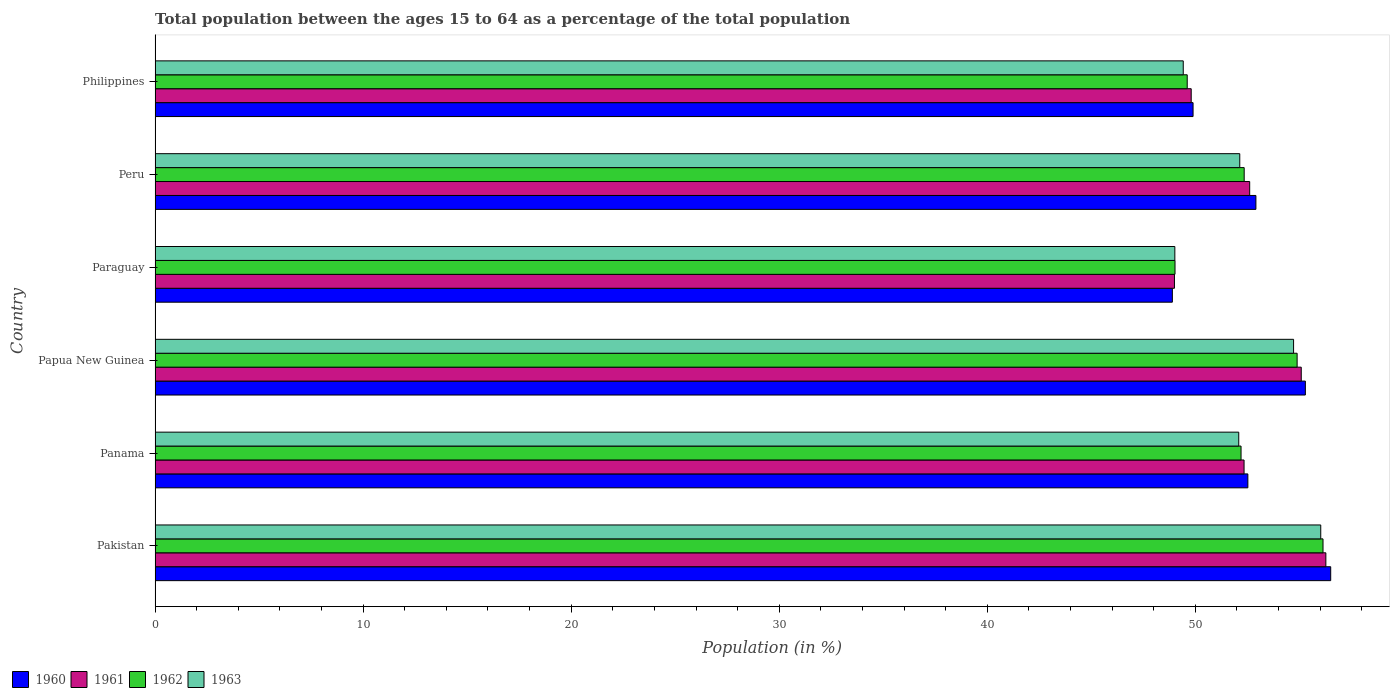How many different coloured bars are there?
Keep it short and to the point. 4. How many groups of bars are there?
Provide a short and direct response. 6. How many bars are there on the 5th tick from the bottom?
Your response must be concise. 4. What is the label of the 4th group of bars from the top?
Give a very brief answer. Papua New Guinea. What is the percentage of the population ages 15 to 64 in 1963 in Paraguay?
Your answer should be very brief. 49.01. Across all countries, what is the maximum percentage of the population ages 15 to 64 in 1961?
Your answer should be compact. 56.27. Across all countries, what is the minimum percentage of the population ages 15 to 64 in 1960?
Provide a short and direct response. 48.9. In which country was the percentage of the population ages 15 to 64 in 1961 maximum?
Offer a terse response. Pakistan. In which country was the percentage of the population ages 15 to 64 in 1961 minimum?
Offer a terse response. Paraguay. What is the total percentage of the population ages 15 to 64 in 1961 in the graph?
Provide a short and direct response. 315.11. What is the difference between the percentage of the population ages 15 to 64 in 1960 in Paraguay and that in Philippines?
Your answer should be compact. -0.99. What is the difference between the percentage of the population ages 15 to 64 in 1960 in Peru and the percentage of the population ages 15 to 64 in 1962 in Pakistan?
Offer a very short reply. -3.23. What is the average percentage of the population ages 15 to 64 in 1962 per country?
Keep it short and to the point. 52.37. What is the difference between the percentage of the population ages 15 to 64 in 1960 and percentage of the population ages 15 to 64 in 1963 in Paraguay?
Keep it short and to the point. -0.12. In how many countries, is the percentage of the population ages 15 to 64 in 1963 greater than 16 ?
Provide a short and direct response. 6. What is the ratio of the percentage of the population ages 15 to 64 in 1960 in Paraguay to that in Philippines?
Provide a succinct answer. 0.98. Is the percentage of the population ages 15 to 64 in 1961 in Pakistan less than that in Paraguay?
Make the answer very short. No. Is the difference between the percentage of the population ages 15 to 64 in 1960 in Panama and Philippines greater than the difference between the percentage of the population ages 15 to 64 in 1963 in Panama and Philippines?
Give a very brief answer. No. What is the difference between the highest and the second highest percentage of the population ages 15 to 64 in 1963?
Provide a short and direct response. 1.31. What is the difference between the highest and the lowest percentage of the population ages 15 to 64 in 1962?
Your answer should be very brief. 7.11. What does the 3rd bar from the top in Papua New Guinea represents?
Offer a terse response. 1961. Is it the case that in every country, the sum of the percentage of the population ages 15 to 64 in 1963 and percentage of the population ages 15 to 64 in 1960 is greater than the percentage of the population ages 15 to 64 in 1962?
Your response must be concise. Yes. Are all the bars in the graph horizontal?
Your response must be concise. Yes. How many countries are there in the graph?
Your answer should be compact. 6. Does the graph contain grids?
Your answer should be compact. No. What is the title of the graph?
Keep it short and to the point. Total population between the ages 15 to 64 as a percentage of the total population. Does "1976" appear as one of the legend labels in the graph?
Provide a succinct answer. No. What is the label or title of the X-axis?
Offer a very short reply. Population (in %). What is the Population (in %) of 1960 in Pakistan?
Give a very brief answer. 56.51. What is the Population (in %) of 1961 in Pakistan?
Make the answer very short. 56.27. What is the Population (in %) in 1962 in Pakistan?
Make the answer very short. 56.14. What is the Population (in %) of 1963 in Pakistan?
Provide a short and direct response. 56.03. What is the Population (in %) of 1960 in Panama?
Offer a terse response. 52.52. What is the Population (in %) in 1961 in Panama?
Your answer should be very brief. 52.34. What is the Population (in %) in 1962 in Panama?
Provide a succinct answer. 52.2. What is the Population (in %) of 1963 in Panama?
Give a very brief answer. 52.09. What is the Population (in %) in 1960 in Papua New Guinea?
Your answer should be very brief. 55.29. What is the Population (in %) of 1961 in Papua New Guinea?
Give a very brief answer. 55.09. What is the Population (in %) in 1962 in Papua New Guinea?
Keep it short and to the point. 54.89. What is the Population (in %) of 1963 in Papua New Guinea?
Keep it short and to the point. 54.72. What is the Population (in %) of 1960 in Paraguay?
Your answer should be very brief. 48.9. What is the Population (in %) of 1961 in Paraguay?
Give a very brief answer. 49. What is the Population (in %) of 1962 in Paraguay?
Provide a succinct answer. 49.02. What is the Population (in %) in 1963 in Paraguay?
Give a very brief answer. 49.01. What is the Population (in %) in 1960 in Peru?
Offer a terse response. 52.91. What is the Population (in %) of 1961 in Peru?
Your answer should be compact. 52.61. What is the Population (in %) of 1962 in Peru?
Ensure brevity in your answer.  52.35. What is the Population (in %) of 1963 in Peru?
Your answer should be very brief. 52.13. What is the Population (in %) in 1960 in Philippines?
Keep it short and to the point. 49.89. What is the Population (in %) of 1961 in Philippines?
Your answer should be very brief. 49.8. What is the Population (in %) in 1962 in Philippines?
Give a very brief answer. 49.61. What is the Population (in %) of 1963 in Philippines?
Make the answer very short. 49.42. Across all countries, what is the maximum Population (in %) in 1960?
Ensure brevity in your answer.  56.51. Across all countries, what is the maximum Population (in %) in 1961?
Provide a short and direct response. 56.27. Across all countries, what is the maximum Population (in %) in 1962?
Offer a terse response. 56.14. Across all countries, what is the maximum Population (in %) of 1963?
Give a very brief answer. 56.03. Across all countries, what is the minimum Population (in %) of 1960?
Your answer should be very brief. 48.9. Across all countries, what is the minimum Population (in %) of 1961?
Your response must be concise. 49. Across all countries, what is the minimum Population (in %) of 1962?
Offer a very short reply. 49.02. Across all countries, what is the minimum Population (in %) of 1963?
Give a very brief answer. 49.01. What is the total Population (in %) of 1960 in the graph?
Give a very brief answer. 316.01. What is the total Population (in %) of 1961 in the graph?
Keep it short and to the point. 315.11. What is the total Population (in %) of 1962 in the graph?
Offer a terse response. 314.2. What is the total Population (in %) of 1963 in the graph?
Your response must be concise. 313.4. What is the difference between the Population (in %) in 1960 in Pakistan and that in Panama?
Your answer should be compact. 3.98. What is the difference between the Population (in %) in 1961 in Pakistan and that in Panama?
Give a very brief answer. 3.93. What is the difference between the Population (in %) of 1962 in Pakistan and that in Panama?
Make the answer very short. 3.94. What is the difference between the Population (in %) of 1963 in Pakistan and that in Panama?
Offer a terse response. 3.94. What is the difference between the Population (in %) of 1960 in Pakistan and that in Papua New Guinea?
Make the answer very short. 1.22. What is the difference between the Population (in %) of 1961 in Pakistan and that in Papua New Guinea?
Your response must be concise. 1.18. What is the difference between the Population (in %) in 1962 in Pakistan and that in Papua New Guinea?
Provide a short and direct response. 1.24. What is the difference between the Population (in %) of 1963 in Pakistan and that in Papua New Guinea?
Offer a very short reply. 1.31. What is the difference between the Population (in %) in 1960 in Pakistan and that in Paraguay?
Your response must be concise. 7.61. What is the difference between the Population (in %) in 1961 in Pakistan and that in Paraguay?
Give a very brief answer. 7.28. What is the difference between the Population (in %) of 1962 in Pakistan and that in Paraguay?
Your answer should be compact. 7.11. What is the difference between the Population (in %) in 1963 in Pakistan and that in Paraguay?
Your answer should be compact. 7.01. What is the difference between the Population (in %) of 1960 in Pakistan and that in Peru?
Your response must be concise. 3.6. What is the difference between the Population (in %) in 1961 in Pakistan and that in Peru?
Your answer should be compact. 3.66. What is the difference between the Population (in %) of 1962 in Pakistan and that in Peru?
Your answer should be compact. 3.79. What is the difference between the Population (in %) of 1963 in Pakistan and that in Peru?
Ensure brevity in your answer.  3.89. What is the difference between the Population (in %) of 1960 in Pakistan and that in Philippines?
Your answer should be compact. 6.62. What is the difference between the Population (in %) of 1961 in Pakistan and that in Philippines?
Offer a very short reply. 6.47. What is the difference between the Population (in %) of 1962 in Pakistan and that in Philippines?
Your answer should be compact. 6.53. What is the difference between the Population (in %) of 1963 in Pakistan and that in Philippines?
Ensure brevity in your answer.  6.61. What is the difference between the Population (in %) of 1960 in Panama and that in Papua New Guinea?
Make the answer very short. -2.76. What is the difference between the Population (in %) of 1961 in Panama and that in Papua New Guinea?
Give a very brief answer. -2.75. What is the difference between the Population (in %) of 1962 in Panama and that in Papua New Guinea?
Your answer should be very brief. -2.7. What is the difference between the Population (in %) in 1963 in Panama and that in Papua New Guinea?
Your response must be concise. -2.64. What is the difference between the Population (in %) in 1960 in Panama and that in Paraguay?
Your answer should be very brief. 3.63. What is the difference between the Population (in %) in 1961 in Panama and that in Paraguay?
Provide a succinct answer. 3.35. What is the difference between the Population (in %) of 1962 in Panama and that in Paraguay?
Your answer should be compact. 3.17. What is the difference between the Population (in %) in 1963 in Panama and that in Paraguay?
Keep it short and to the point. 3.07. What is the difference between the Population (in %) in 1960 in Panama and that in Peru?
Give a very brief answer. -0.39. What is the difference between the Population (in %) in 1961 in Panama and that in Peru?
Your answer should be compact. -0.27. What is the difference between the Population (in %) in 1962 in Panama and that in Peru?
Give a very brief answer. -0.15. What is the difference between the Population (in %) of 1963 in Panama and that in Peru?
Ensure brevity in your answer.  -0.05. What is the difference between the Population (in %) of 1960 in Panama and that in Philippines?
Offer a very short reply. 2.63. What is the difference between the Population (in %) of 1961 in Panama and that in Philippines?
Offer a terse response. 2.54. What is the difference between the Population (in %) of 1962 in Panama and that in Philippines?
Your answer should be compact. 2.59. What is the difference between the Population (in %) of 1963 in Panama and that in Philippines?
Provide a succinct answer. 2.67. What is the difference between the Population (in %) of 1960 in Papua New Guinea and that in Paraguay?
Provide a short and direct response. 6.39. What is the difference between the Population (in %) of 1961 in Papua New Guinea and that in Paraguay?
Give a very brief answer. 6.09. What is the difference between the Population (in %) in 1962 in Papua New Guinea and that in Paraguay?
Keep it short and to the point. 5.87. What is the difference between the Population (in %) of 1963 in Papua New Guinea and that in Paraguay?
Offer a terse response. 5.71. What is the difference between the Population (in %) of 1960 in Papua New Guinea and that in Peru?
Give a very brief answer. 2.38. What is the difference between the Population (in %) in 1961 in Papua New Guinea and that in Peru?
Your response must be concise. 2.48. What is the difference between the Population (in %) of 1962 in Papua New Guinea and that in Peru?
Ensure brevity in your answer.  2.55. What is the difference between the Population (in %) in 1963 in Papua New Guinea and that in Peru?
Offer a terse response. 2.59. What is the difference between the Population (in %) in 1960 in Papua New Guinea and that in Philippines?
Ensure brevity in your answer.  5.4. What is the difference between the Population (in %) of 1961 in Papua New Guinea and that in Philippines?
Keep it short and to the point. 5.29. What is the difference between the Population (in %) in 1962 in Papua New Guinea and that in Philippines?
Your response must be concise. 5.28. What is the difference between the Population (in %) in 1963 in Papua New Guinea and that in Philippines?
Your response must be concise. 5.3. What is the difference between the Population (in %) of 1960 in Paraguay and that in Peru?
Provide a short and direct response. -4.02. What is the difference between the Population (in %) in 1961 in Paraguay and that in Peru?
Provide a succinct answer. -3.62. What is the difference between the Population (in %) in 1962 in Paraguay and that in Peru?
Ensure brevity in your answer.  -3.32. What is the difference between the Population (in %) of 1963 in Paraguay and that in Peru?
Provide a short and direct response. -3.12. What is the difference between the Population (in %) in 1960 in Paraguay and that in Philippines?
Offer a terse response. -0.99. What is the difference between the Population (in %) of 1961 in Paraguay and that in Philippines?
Ensure brevity in your answer.  -0.81. What is the difference between the Population (in %) in 1962 in Paraguay and that in Philippines?
Your response must be concise. -0.59. What is the difference between the Population (in %) of 1963 in Paraguay and that in Philippines?
Your answer should be compact. -0.4. What is the difference between the Population (in %) in 1960 in Peru and that in Philippines?
Give a very brief answer. 3.02. What is the difference between the Population (in %) of 1961 in Peru and that in Philippines?
Give a very brief answer. 2.81. What is the difference between the Population (in %) in 1962 in Peru and that in Philippines?
Keep it short and to the point. 2.74. What is the difference between the Population (in %) in 1963 in Peru and that in Philippines?
Offer a terse response. 2.72. What is the difference between the Population (in %) of 1960 in Pakistan and the Population (in %) of 1961 in Panama?
Make the answer very short. 4.16. What is the difference between the Population (in %) in 1960 in Pakistan and the Population (in %) in 1962 in Panama?
Ensure brevity in your answer.  4.31. What is the difference between the Population (in %) in 1960 in Pakistan and the Population (in %) in 1963 in Panama?
Your response must be concise. 4.42. What is the difference between the Population (in %) of 1961 in Pakistan and the Population (in %) of 1962 in Panama?
Provide a succinct answer. 4.08. What is the difference between the Population (in %) of 1961 in Pakistan and the Population (in %) of 1963 in Panama?
Provide a succinct answer. 4.19. What is the difference between the Population (in %) in 1962 in Pakistan and the Population (in %) in 1963 in Panama?
Keep it short and to the point. 4.05. What is the difference between the Population (in %) in 1960 in Pakistan and the Population (in %) in 1961 in Papua New Guinea?
Provide a succinct answer. 1.42. What is the difference between the Population (in %) of 1960 in Pakistan and the Population (in %) of 1962 in Papua New Guinea?
Offer a terse response. 1.61. What is the difference between the Population (in %) of 1960 in Pakistan and the Population (in %) of 1963 in Papua New Guinea?
Keep it short and to the point. 1.78. What is the difference between the Population (in %) of 1961 in Pakistan and the Population (in %) of 1962 in Papua New Guinea?
Ensure brevity in your answer.  1.38. What is the difference between the Population (in %) in 1961 in Pakistan and the Population (in %) in 1963 in Papua New Guinea?
Your response must be concise. 1.55. What is the difference between the Population (in %) of 1962 in Pakistan and the Population (in %) of 1963 in Papua New Guinea?
Your response must be concise. 1.41. What is the difference between the Population (in %) of 1960 in Pakistan and the Population (in %) of 1961 in Paraguay?
Provide a short and direct response. 7.51. What is the difference between the Population (in %) of 1960 in Pakistan and the Population (in %) of 1962 in Paraguay?
Your response must be concise. 7.48. What is the difference between the Population (in %) of 1960 in Pakistan and the Population (in %) of 1963 in Paraguay?
Make the answer very short. 7.49. What is the difference between the Population (in %) of 1961 in Pakistan and the Population (in %) of 1962 in Paraguay?
Your response must be concise. 7.25. What is the difference between the Population (in %) in 1961 in Pakistan and the Population (in %) in 1963 in Paraguay?
Your answer should be very brief. 7.26. What is the difference between the Population (in %) in 1962 in Pakistan and the Population (in %) in 1963 in Paraguay?
Your answer should be compact. 7.12. What is the difference between the Population (in %) in 1960 in Pakistan and the Population (in %) in 1961 in Peru?
Provide a short and direct response. 3.89. What is the difference between the Population (in %) of 1960 in Pakistan and the Population (in %) of 1962 in Peru?
Give a very brief answer. 4.16. What is the difference between the Population (in %) of 1960 in Pakistan and the Population (in %) of 1963 in Peru?
Your answer should be very brief. 4.37. What is the difference between the Population (in %) of 1961 in Pakistan and the Population (in %) of 1962 in Peru?
Your answer should be compact. 3.93. What is the difference between the Population (in %) in 1961 in Pakistan and the Population (in %) in 1963 in Peru?
Provide a succinct answer. 4.14. What is the difference between the Population (in %) in 1962 in Pakistan and the Population (in %) in 1963 in Peru?
Your response must be concise. 4. What is the difference between the Population (in %) in 1960 in Pakistan and the Population (in %) in 1961 in Philippines?
Keep it short and to the point. 6.71. What is the difference between the Population (in %) of 1960 in Pakistan and the Population (in %) of 1962 in Philippines?
Keep it short and to the point. 6.9. What is the difference between the Population (in %) of 1960 in Pakistan and the Population (in %) of 1963 in Philippines?
Make the answer very short. 7.09. What is the difference between the Population (in %) in 1961 in Pakistan and the Population (in %) in 1962 in Philippines?
Make the answer very short. 6.66. What is the difference between the Population (in %) in 1961 in Pakistan and the Population (in %) in 1963 in Philippines?
Provide a succinct answer. 6.85. What is the difference between the Population (in %) of 1962 in Pakistan and the Population (in %) of 1963 in Philippines?
Provide a short and direct response. 6.72. What is the difference between the Population (in %) in 1960 in Panama and the Population (in %) in 1961 in Papua New Guinea?
Provide a short and direct response. -2.57. What is the difference between the Population (in %) in 1960 in Panama and the Population (in %) in 1962 in Papua New Guinea?
Your response must be concise. -2.37. What is the difference between the Population (in %) in 1960 in Panama and the Population (in %) in 1963 in Papua New Guinea?
Make the answer very short. -2.2. What is the difference between the Population (in %) of 1961 in Panama and the Population (in %) of 1962 in Papua New Guinea?
Your answer should be compact. -2.55. What is the difference between the Population (in %) in 1961 in Panama and the Population (in %) in 1963 in Papua New Guinea?
Offer a terse response. -2.38. What is the difference between the Population (in %) in 1962 in Panama and the Population (in %) in 1963 in Papua New Guinea?
Your answer should be very brief. -2.52. What is the difference between the Population (in %) of 1960 in Panama and the Population (in %) of 1961 in Paraguay?
Provide a succinct answer. 3.53. What is the difference between the Population (in %) in 1960 in Panama and the Population (in %) in 1962 in Paraguay?
Make the answer very short. 3.5. What is the difference between the Population (in %) of 1960 in Panama and the Population (in %) of 1963 in Paraguay?
Keep it short and to the point. 3.51. What is the difference between the Population (in %) in 1961 in Panama and the Population (in %) in 1962 in Paraguay?
Your answer should be very brief. 3.32. What is the difference between the Population (in %) of 1961 in Panama and the Population (in %) of 1963 in Paraguay?
Provide a succinct answer. 3.33. What is the difference between the Population (in %) of 1962 in Panama and the Population (in %) of 1963 in Paraguay?
Offer a very short reply. 3.18. What is the difference between the Population (in %) in 1960 in Panama and the Population (in %) in 1961 in Peru?
Offer a terse response. -0.09. What is the difference between the Population (in %) of 1960 in Panama and the Population (in %) of 1962 in Peru?
Provide a short and direct response. 0.18. What is the difference between the Population (in %) of 1960 in Panama and the Population (in %) of 1963 in Peru?
Ensure brevity in your answer.  0.39. What is the difference between the Population (in %) in 1961 in Panama and the Population (in %) in 1962 in Peru?
Your answer should be compact. -0.01. What is the difference between the Population (in %) in 1961 in Panama and the Population (in %) in 1963 in Peru?
Provide a short and direct response. 0.21. What is the difference between the Population (in %) in 1962 in Panama and the Population (in %) in 1963 in Peru?
Offer a very short reply. 0.06. What is the difference between the Population (in %) in 1960 in Panama and the Population (in %) in 1961 in Philippines?
Offer a terse response. 2.72. What is the difference between the Population (in %) of 1960 in Panama and the Population (in %) of 1962 in Philippines?
Ensure brevity in your answer.  2.91. What is the difference between the Population (in %) of 1960 in Panama and the Population (in %) of 1963 in Philippines?
Provide a short and direct response. 3.11. What is the difference between the Population (in %) of 1961 in Panama and the Population (in %) of 1962 in Philippines?
Provide a short and direct response. 2.73. What is the difference between the Population (in %) of 1961 in Panama and the Population (in %) of 1963 in Philippines?
Ensure brevity in your answer.  2.92. What is the difference between the Population (in %) of 1962 in Panama and the Population (in %) of 1963 in Philippines?
Give a very brief answer. 2.78. What is the difference between the Population (in %) of 1960 in Papua New Guinea and the Population (in %) of 1961 in Paraguay?
Give a very brief answer. 6.29. What is the difference between the Population (in %) of 1960 in Papua New Guinea and the Population (in %) of 1962 in Paraguay?
Your response must be concise. 6.27. What is the difference between the Population (in %) in 1960 in Papua New Guinea and the Population (in %) in 1963 in Paraguay?
Offer a terse response. 6.27. What is the difference between the Population (in %) of 1961 in Papua New Guinea and the Population (in %) of 1962 in Paraguay?
Your answer should be very brief. 6.07. What is the difference between the Population (in %) in 1961 in Papua New Guinea and the Population (in %) in 1963 in Paraguay?
Your response must be concise. 6.08. What is the difference between the Population (in %) of 1962 in Papua New Guinea and the Population (in %) of 1963 in Paraguay?
Your answer should be compact. 5.88. What is the difference between the Population (in %) in 1960 in Papua New Guinea and the Population (in %) in 1961 in Peru?
Provide a short and direct response. 2.68. What is the difference between the Population (in %) in 1960 in Papua New Guinea and the Population (in %) in 1962 in Peru?
Your answer should be compact. 2.94. What is the difference between the Population (in %) of 1960 in Papua New Guinea and the Population (in %) of 1963 in Peru?
Your answer should be very brief. 3.15. What is the difference between the Population (in %) in 1961 in Papua New Guinea and the Population (in %) in 1962 in Peru?
Provide a succinct answer. 2.74. What is the difference between the Population (in %) of 1961 in Papua New Guinea and the Population (in %) of 1963 in Peru?
Your answer should be compact. 2.96. What is the difference between the Population (in %) of 1962 in Papua New Guinea and the Population (in %) of 1963 in Peru?
Your answer should be very brief. 2.76. What is the difference between the Population (in %) in 1960 in Papua New Guinea and the Population (in %) in 1961 in Philippines?
Your answer should be very brief. 5.49. What is the difference between the Population (in %) of 1960 in Papua New Guinea and the Population (in %) of 1962 in Philippines?
Provide a short and direct response. 5.68. What is the difference between the Population (in %) in 1960 in Papua New Guinea and the Population (in %) in 1963 in Philippines?
Offer a terse response. 5.87. What is the difference between the Population (in %) in 1961 in Papua New Guinea and the Population (in %) in 1962 in Philippines?
Give a very brief answer. 5.48. What is the difference between the Population (in %) in 1961 in Papua New Guinea and the Population (in %) in 1963 in Philippines?
Offer a terse response. 5.67. What is the difference between the Population (in %) of 1962 in Papua New Guinea and the Population (in %) of 1963 in Philippines?
Your response must be concise. 5.47. What is the difference between the Population (in %) of 1960 in Paraguay and the Population (in %) of 1961 in Peru?
Offer a very short reply. -3.72. What is the difference between the Population (in %) in 1960 in Paraguay and the Population (in %) in 1962 in Peru?
Provide a succinct answer. -3.45. What is the difference between the Population (in %) in 1960 in Paraguay and the Population (in %) in 1963 in Peru?
Offer a terse response. -3.24. What is the difference between the Population (in %) of 1961 in Paraguay and the Population (in %) of 1962 in Peru?
Offer a very short reply. -3.35. What is the difference between the Population (in %) of 1961 in Paraguay and the Population (in %) of 1963 in Peru?
Offer a terse response. -3.14. What is the difference between the Population (in %) in 1962 in Paraguay and the Population (in %) in 1963 in Peru?
Offer a very short reply. -3.11. What is the difference between the Population (in %) of 1960 in Paraguay and the Population (in %) of 1961 in Philippines?
Offer a terse response. -0.91. What is the difference between the Population (in %) of 1960 in Paraguay and the Population (in %) of 1962 in Philippines?
Your response must be concise. -0.71. What is the difference between the Population (in %) of 1960 in Paraguay and the Population (in %) of 1963 in Philippines?
Provide a short and direct response. -0.52. What is the difference between the Population (in %) in 1961 in Paraguay and the Population (in %) in 1962 in Philippines?
Your answer should be very brief. -0.61. What is the difference between the Population (in %) in 1961 in Paraguay and the Population (in %) in 1963 in Philippines?
Your answer should be compact. -0.42. What is the difference between the Population (in %) of 1962 in Paraguay and the Population (in %) of 1963 in Philippines?
Offer a terse response. -0.4. What is the difference between the Population (in %) of 1960 in Peru and the Population (in %) of 1961 in Philippines?
Ensure brevity in your answer.  3.11. What is the difference between the Population (in %) of 1960 in Peru and the Population (in %) of 1962 in Philippines?
Provide a succinct answer. 3.3. What is the difference between the Population (in %) in 1960 in Peru and the Population (in %) in 1963 in Philippines?
Make the answer very short. 3.49. What is the difference between the Population (in %) of 1961 in Peru and the Population (in %) of 1962 in Philippines?
Provide a short and direct response. 3. What is the difference between the Population (in %) in 1961 in Peru and the Population (in %) in 1963 in Philippines?
Provide a short and direct response. 3.19. What is the difference between the Population (in %) in 1962 in Peru and the Population (in %) in 1963 in Philippines?
Your answer should be very brief. 2.93. What is the average Population (in %) of 1960 per country?
Give a very brief answer. 52.67. What is the average Population (in %) in 1961 per country?
Keep it short and to the point. 52.52. What is the average Population (in %) in 1962 per country?
Ensure brevity in your answer.  52.37. What is the average Population (in %) in 1963 per country?
Your answer should be compact. 52.23. What is the difference between the Population (in %) in 1960 and Population (in %) in 1961 in Pakistan?
Keep it short and to the point. 0.23. What is the difference between the Population (in %) in 1960 and Population (in %) in 1962 in Pakistan?
Offer a very short reply. 0.37. What is the difference between the Population (in %) in 1960 and Population (in %) in 1963 in Pakistan?
Keep it short and to the point. 0.48. What is the difference between the Population (in %) of 1961 and Population (in %) of 1962 in Pakistan?
Your response must be concise. 0.14. What is the difference between the Population (in %) in 1961 and Population (in %) in 1963 in Pakistan?
Make the answer very short. 0.25. What is the difference between the Population (in %) of 1962 and Population (in %) of 1963 in Pakistan?
Ensure brevity in your answer.  0.11. What is the difference between the Population (in %) in 1960 and Population (in %) in 1961 in Panama?
Your response must be concise. 0.18. What is the difference between the Population (in %) of 1960 and Population (in %) of 1962 in Panama?
Give a very brief answer. 0.33. What is the difference between the Population (in %) in 1960 and Population (in %) in 1963 in Panama?
Give a very brief answer. 0.44. What is the difference between the Population (in %) of 1961 and Population (in %) of 1962 in Panama?
Offer a very short reply. 0.15. What is the difference between the Population (in %) of 1961 and Population (in %) of 1963 in Panama?
Keep it short and to the point. 0.26. What is the difference between the Population (in %) of 1962 and Population (in %) of 1963 in Panama?
Your answer should be very brief. 0.11. What is the difference between the Population (in %) of 1960 and Population (in %) of 1961 in Papua New Guinea?
Offer a terse response. 0.2. What is the difference between the Population (in %) in 1960 and Population (in %) in 1962 in Papua New Guinea?
Offer a very short reply. 0.4. What is the difference between the Population (in %) of 1960 and Population (in %) of 1963 in Papua New Guinea?
Provide a succinct answer. 0.57. What is the difference between the Population (in %) of 1961 and Population (in %) of 1962 in Papua New Guinea?
Keep it short and to the point. 0.2. What is the difference between the Population (in %) in 1961 and Population (in %) in 1963 in Papua New Guinea?
Your answer should be very brief. 0.37. What is the difference between the Population (in %) in 1962 and Population (in %) in 1963 in Papua New Guinea?
Give a very brief answer. 0.17. What is the difference between the Population (in %) in 1960 and Population (in %) in 1961 in Paraguay?
Your answer should be compact. -0.1. What is the difference between the Population (in %) in 1960 and Population (in %) in 1962 in Paraguay?
Provide a short and direct response. -0.13. What is the difference between the Population (in %) of 1960 and Population (in %) of 1963 in Paraguay?
Your answer should be very brief. -0.12. What is the difference between the Population (in %) of 1961 and Population (in %) of 1962 in Paraguay?
Provide a short and direct response. -0.03. What is the difference between the Population (in %) of 1961 and Population (in %) of 1963 in Paraguay?
Your response must be concise. -0.02. What is the difference between the Population (in %) in 1962 and Population (in %) in 1963 in Paraguay?
Provide a short and direct response. 0.01. What is the difference between the Population (in %) of 1960 and Population (in %) of 1961 in Peru?
Your answer should be compact. 0.3. What is the difference between the Population (in %) in 1960 and Population (in %) in 1962 in Peru?
Your answer should be very brief. 0.56. What is the difference between the Population (in %) in 1960 and Population (in %) in 1963 in Peru?
Provide a succinct answer. 0.78. What is the difference between the Population (in %) of 1961 and Population (in %) of 1962 in Peru?
Your response must be concise. 0.26. What is the difference between the Population (in %) of 1961 and Population (in %) of 1963 in Peru?
Provide a short and direct response. 0.48. What is the difference between the Population (in %) of 1962 and Population (in %) of 1963 in Peru?
Offer a very short reply. 0.21. What is the difference between the Population (in %) of 1960 and Population (in %) of 1961 in Philippines?
Provide a succinct answer. 0.09. What is the difference between the Population (in %) in 1960 and Population (in %) in 1962 in Philippines?
Ensure brevity in your answer.  0.28. What is the difference between the Population (in %) in 1960 and Population (in %) in 1963 in Philippines?
Offer a terse response. 0.47. What is the difference between the Population (in %) of 1961 and Population (in %) of 1962 in Philippines?
Make the answer very short. 0.19. What is the difference between the Population (in %) of 1961 and Population (in %) of 1963 in Philippines?
Your answer should be very brief. 0.38. What is the difference between the Population (in %) of 1962 and Population (in %) of 1963 in Philippines?
Ensure brevity in your answer.  0.19. What is the ratio of the Population (in %) in 1960 in Pakistan to that in Panama?
Give a very brief answer. 1.08. What is the ratio of the Population (in %) in 1961 in Pakistan to that in Panama?
Offer a very short reply. 1.08. What is the ratio of the Population (in %) in 1962 in Pakistan to that in Panama?
Offer a very short reply. 1.08. What is the ratio of the Population (in %) of 1963 in Pakistan to that in Panama?
Give a very brief answer. 1.08. What is the ratio of the Population (in %) of 1961 in Pakistan to that in Papua New Guinea?
Provide a short and direct response. 1.02. What is the ratio of the Population (in %) of 1962 in Pakistan to that in Papua New Guinea?
Your answer should be compact. 1.02. What is the ratio of the Population (in %) of 1963 in Pakistan to that in Papua New Guinea?
Make the answer very short. 1.02. What is the ratio of the Population (in %) of 1960 in Pakistan to that in Paraguay?
Ensure brevity in your answer.  1.16. What is the ratio of the Population (in %) of 1961 in Pakistan to that in Paraguay?
Ensure brevity in your answer.  1.15. What is the ratio of the Population (in %) in 1962 in Pakistan to that in Paraguay?
Offer a terse response. 1.15. What is the ratio of the Population (in %) in 1963 in Pakistan to that in Paraguay?
Your answer should be compact. 1.14. What is the ratio of the Population (in %) in 1960 in Pakistan to that in Peru?
Your answer should be very brief. 1.07. What is the ratio of the Population (in %) in 1961 in Pakistan to that in Peru?
Offer a terse response. 1.07. What is the ratio of the Population (in %) of 1962 in Pakistan to that in Peru?
Offer a very short reply. 1.07. What is the ratio of the Population (in %) in 1963 in Pakistan to that in Peru?
Keep it short and to the point. 1.07. What is the ratio of the Population (in %) in 1960 in Pakistan to that in Philippines?
Offer a terse response. 1.13. What is the ratio of the Population (in %) in 1961 in Pakistan to that in Philippines?
Provide a succinct answer. 1.13. What is the ratio of the Population (in %) in 1962 in Pakistan to that in Philippines?
Provide a short and direct response. 1.13. What is the ratio of the Population (in %) in 1963 in Pakistan to that in Philippines?
Give a very brief answer. 1.13. What is the ratio of the Population (in %) in 1960 in Panama to that in Papua New Guinea?
Your response must be concise. 0.95. What is the ratio of the Population (in %) in 1961 in Panama to that in Papua New Guinea?
Offer a very short reply. 0.95. What is the ratio of the Population (in %) in 1962 in Panama to that in Papua New Guinea?
Your response must be concise. 0.95. What is the ratio of the Population (in %) of 1963 in Panama to that in Papua New Guinea?
Offer a very short reply. 0.95. What is the ratio of the Population (in %) of 1960 in Panama to that in Paraguay?
Your response must be concise. 1.07. What is the ratio of the Population (in %) in 1961 in Panama to that in Paraguay?
Your answer should be very brief. 1.07. What is the ratio of the Population (in %) of 1962 in Panama to that in Paraguay?
Your answer should be very brief. 1.06. What is the ratio of the Population (in %) of 1963 in Panama to that in Paraguay?
Make the answer very short. 1.06. What is the ratio of the Population (in %) in 1962 in Panama to that in Peru?
Provide a succinct answer. 1. What is the ratio of the Population (in %) of 1963 in Panama to that in Peru?
Ensure brevity in your answer.  1. What is the ratio of the Population (in %) of 1960 in Panama to that in Philippines?
Ensure brevity in your answer.  1.05. What is the ratio of the Population (in %) in 1961 in Panama to that in Philippines?
Keep it short and to the point. 1.05. What is the ratio of the Population (in %) in 1962 in Panama to that in Philippines?
Offer a very short reply. 1.05. What is the ratio of the Population (in %) in 1963 in Panama to that in Philippines?
Ensure brevity in your answer.  1.05. What is the ratio of the Population (in %) in 1960 in Papua New Guinea to that in Paraguay?
Provide a short and direct response. 1.13. What is the ratio of the Population (in %) of 1961 in Papua New Guinea to that in Paraguay?
Make the answer very short. 1.12. What is the ratio of the Population (in %) of 1962 in Papua New Guinea to that in Paraguay?
Ensure brevity in your answer.  1.12. What is the ratio of the Population (in %) of 1963 in Papua New Guinea to that in Paraguay?
Ensure brevity in your answer.  1.12. What is the ratio of the Population (in %) in 1960 in Papua New Guinea to that in Peru?
Provide a succinct answer. 1.04. What is the ratio of the Population (in %) of 1961 in Papua New Guinea to that in Peru?
Make the answer very short. 1.05. What is the ratio of the Population (in %) in 1962 in Papua New Guinea to that in Peru?
Keep it short and to the point. 1.05. What is the ratio of the Population (in %) in 1963 in Papua New Guinea to that in Peru?
Offer a terse response. 1.05. What is the ratio of the Population (in %) of 1960 in Papua New Guinea to that in Philippines?
Your answer should be very brief. 1.11. What is the ratio of the Population (in %) of 1961 in Papua New Guinea to that in Philippines?
Make the answer very short. 1.11. What is the ratio of the Population (in %) in 1962 in Papua New Guinea to that in Philippines?
Your response must be concise. 1.11. What is the ratio of the Population (in %) in 1963 in Papua New Guinea to that in Philippines?
Your response must be concise. 1.11. What is the ratio of the Population (in %) in 1960 in Paraguay to that in Peru?
Provide a short and direct response. 0.92. What is the ratio of the Population (in %) of 1961 in Paraguay to that in Peru?
Your response must be concise. 0.93. What is the ratio of the Population (in %) in 1962 in Paraguay to that in Peru?
Offer a very short reply. 0.94. What is the ratio of the Population (in %) of 1963 in Paraguay to that in Peru?
Ensure brevity in your answer.  0.94. What is the ratio of the Population (in %) of 1960 in Paraguay to that in Philippines?
Your response must be concise. 0.98. What is the ratio of the Population (in %) in 1961 in Paraguay to that in Philippines?
Make the answer very short. 0.98. What is the ratio of the Population (in %) of 1960 in Peru to that in Philippines?
Offer a very short reply. 1.06. What is the ratio of the Population (in %) in 1961 in Peru to that in Philippines?
Give a very brief answer. 1.06. What is the ratio of the Population (in %) in 1962 in Peru to that in Philippines?
Provide a short and direct response. 1.06. What is the ratio of the Population (in %) of 1963 in Peru to that in Philippines?
Offer a very short reply. 1.05. What is the difference between the highest and the second highest Population (in %) in 1960?
Your answer should be compact. 1.22. What is the difference between the highest and the second highest Population (in %) in 1961?
Keep it short and to the point. 1.18. What is the difference between the highest and the second highest Population (in %) in 1962?
Your answer should be compact. 1.24. What is the difference between the highest and the second highest Population (in %) in 1963?
Provide a short and direct response. 1.31. What is the difference between the highest and the lowest Population (in %) of 1960?
Offer a very short reply. 7.61. What is the difference between the highest and the lowest Population (in %) of 1961?
Keep it short and to the point. 7.28. What is the difference between the highest and the lowest Population (in %) of 1962?
Your response must be concise. 7.11. What is the difference between the highest and the lowest Population (in %) of 1963?
Give a very brief answer. 7.01. 